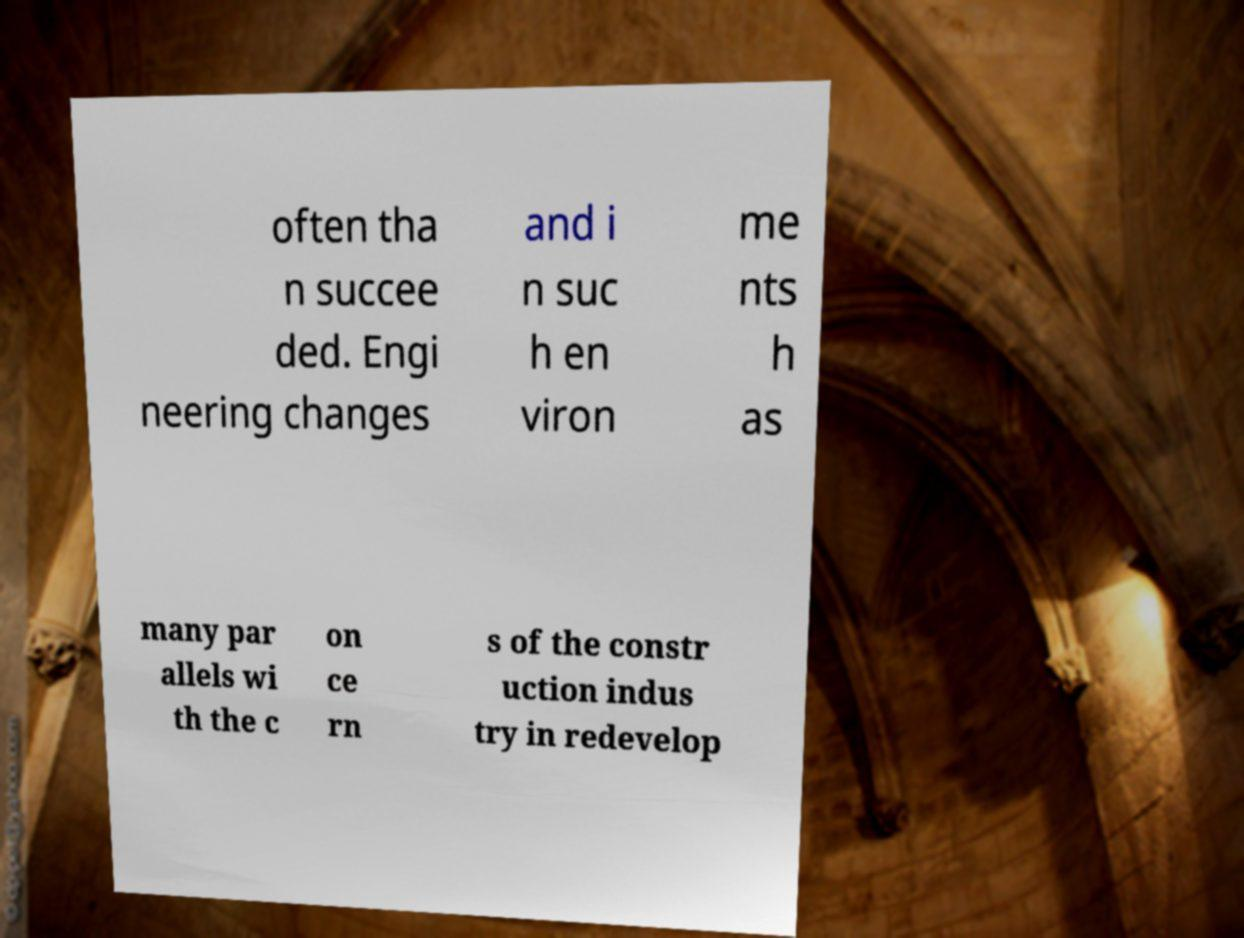There's text embedded in this image that I need extracted. Can you transcribe it verbatim? often tha n succee ded. Engi neering changes and i n suc h en viron me nts h as many par allels wi th the c on ce rn s of the constr uction indus try in redevelop 